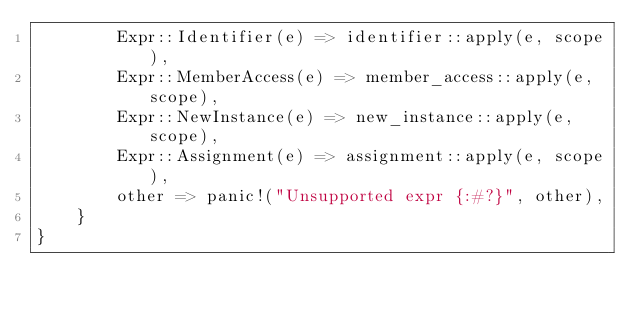<code> <loc_0><loc_0><loc_500><loc_500><_Rust_>        Expr::Identifier(e) => identifier::apply(e, scope),
        Expr::MemberAccess(e) => member_access::apply(e, scope),
        Expr::NewInstance(e) => new_instance::apply(e, scope),
        Expr::Assignment(e) => assignment::apply(e, scope),
        other => panic!("Unsupported expr {:#?}", other),
    }
}
</code> 